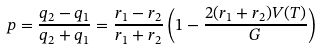Convert formula to latex. <formula><loc_0><loc_0><loc_500><loc_500>p = \frac { q _ { 2 } - q _ { 1 } } { q _ { 2 } + q _ { 1 } } = \frac { r _ { 1 } - r _ { 2 } } { r _ { 1 } + r _ { 2 } } \left ( 1 - \frac { 2 ( r _ { 1 } + r _ { 2 } ) V ( T ) } { G } \right )</formula> 